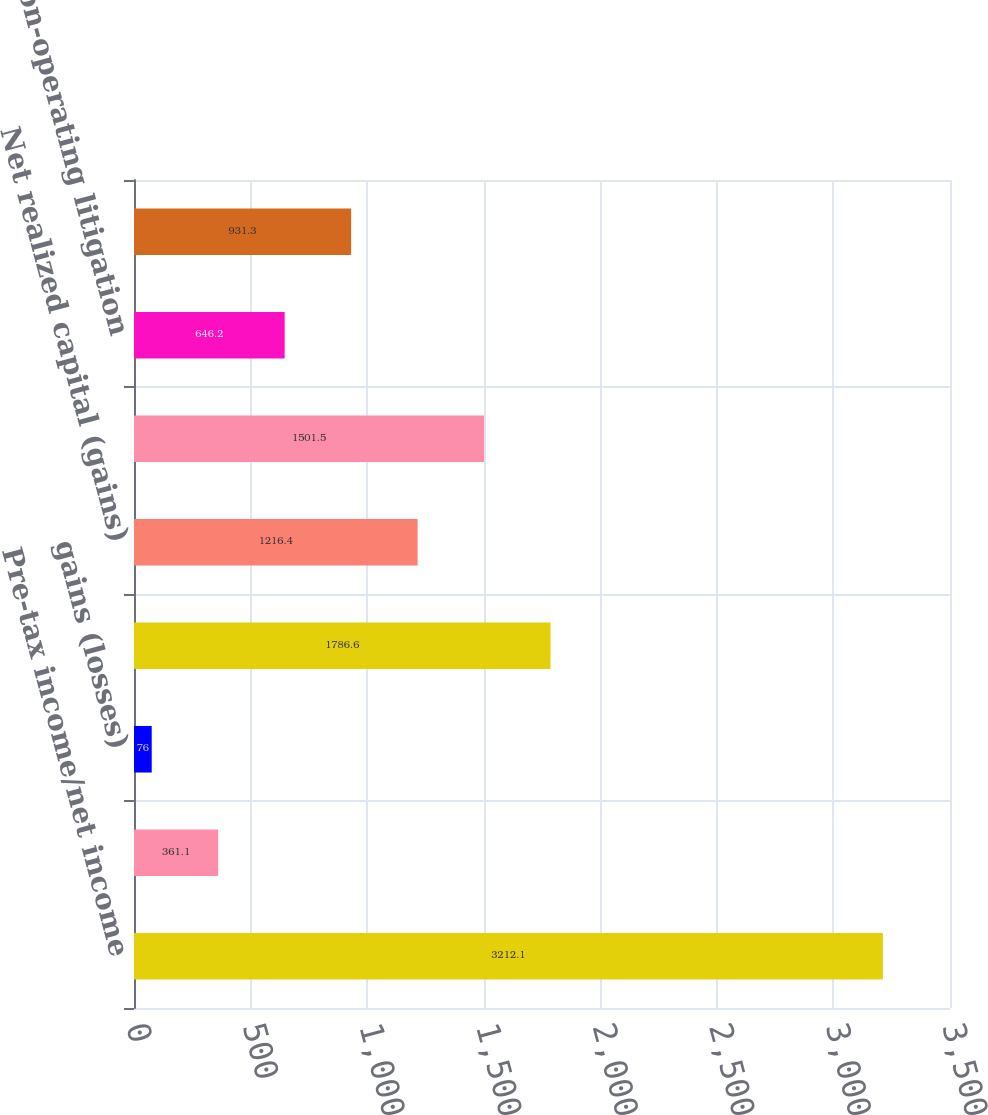<chart> <loc_0><loc_0><loc_500><loc_500><bar_chart><fcel>Pre-tax income/net income<fcel>hedge guaranteed living<fcel>gains (losses)<fcel>Loss on extinguishment of debt<fcel>Net realized capital (gains)<fcel>(Income) loss from divested<fcel>Non-operating litigation<fcel>Net loss reserve discount<nl><fcel>3212.1<fcel>361.1<fcel>76<fcel>1786.6<fcel>1216.4<fcel>1501.5<fcel>646.2<fcel>931.3<nl></chart> 